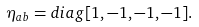Convert formula to latex. <formula><loc_0><loc_0><loc_500><loc_500>\eta _ { a b } = d i a g [ 1 , - 1 , - 1 , - 1 ] .</formula> 